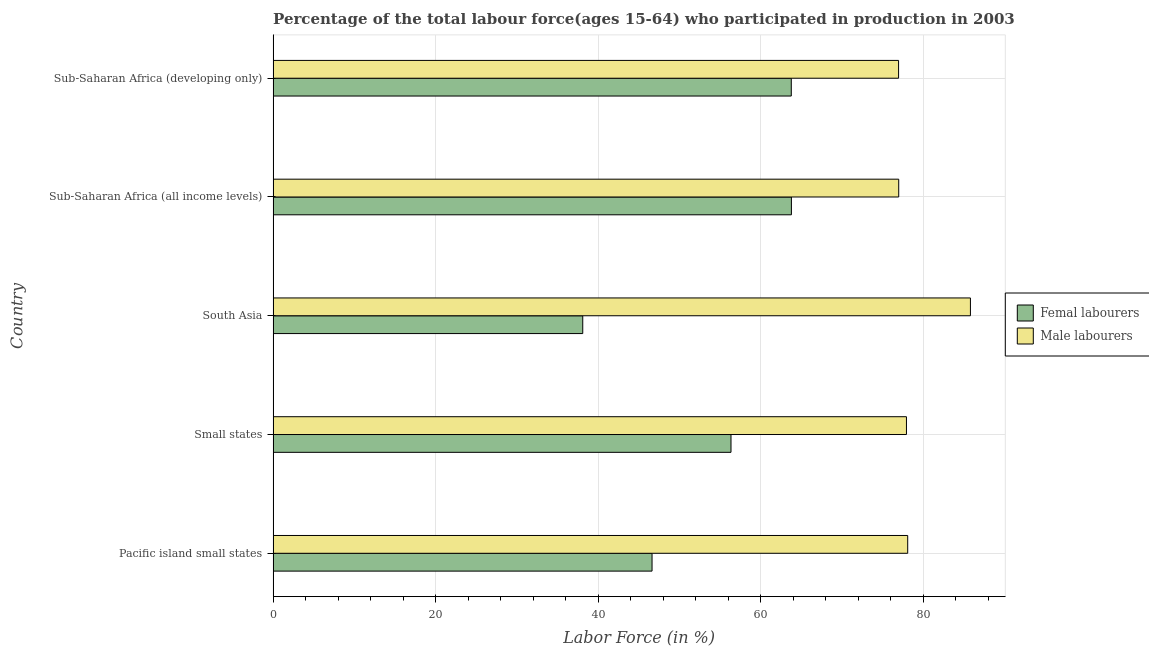How many different coloured bars are there?
Provide a succinct answer. 2. Are the number of bars per tick equal to the number of legend labels?
Your answer should be compact. Yes. Are the number of bars on each tick of the Y-axis equal?
Your answer should be compact. Yes. How many bars are there on the 2nd tick from the top?
Ensure brevity in your answer.  2. How many bars are there on the 3rd tick from the bottom?
Your answer should be compact. 2. In how many cases, is the number of bars for a given country not equal to the number of legend labels?
Offer a very short reply. 0. What is the percentage of male labour force in Small states?
Your answer should be very brief. 77.92. Across all countries, what is the maximum percentage of female labor force?
Your response must be concise. 63.77. Across all countries, what is the minimum percentage of female labor force?
Offer a terse response. 38.09. In which country was the percentage of female labor force maximum?
Ensure brevity in your answer.  Sub-Saharan Africa (all income levels). What is the total percentage of female labor force in the graph?
Make the answer very short. 268.56. What is the difference between the percentage of male labour force in Small states and that in Sub-Saharan Africa (developing only)?
Your response must be concise. 0.97. What is the difference between the percentage of female labor force in Sub-Saharan Africa (all income levels) and the percentage of male labour force in Small states?
Provide a succinct answer. -14.15. What is the average percentage of male labour force per country?
Offer a very short reply. 79.14. What is the difference between the percentage of female labor force and percentage of male labour force in Sub-Saharan Africa (all income levels)?
Provide a short and direct response. -13.2. What is the ratio of the percentage of female labor force in South Asia to that in Sub-Saharan Africa (all income levels)?
Your answer should be compact. 0.6. Is the percentage of female labor force in South Asia less than that in Sub-Saharan Africa (developing only)?
Keep it short and to the point. Yes. What is the difference between the highest and the second highest percentage of male labour force?
Make the answer very short. 7.72. What is the difference between the highest and the lowest percentage of female labor force?
Provide a succinct answer. 25.67. Is the sum of the percentage of female labor force in South Asia and Sub-Saharan Africa (all income levels) greater than the maximum percentage of male labour force across all countries?
Keep it short and to the point. Yes. What does the 2nd bar from the top in Sub-Saharan Africa (all income levels) represents?
Provide a short and direct response. Femal labourers. What does the 2nd bar from the bottom in Small states represents?
Ensure brevity in your answer.  Male labourers. How many countries are there in the graph?
Make the answer very short. 5. Does the graph contain grids?
Make the answer very short. Yes. What is the title of the graph?
Provide a succinct answer. Percentage of the total labour force(ages 15-64) who participated in production in 2003. Does "Travel Items" appear as one of the legend labels in the graph?
Keep it short and to the point. No. What is the label or title of the X-axis?
Offer a very short reply. Labor Force (in %). What is the Labor Force (in %) of Femal labourers in Pacific island small states?
Ensure brevity in your answer.  46.62. What is the Labor Force (in %) in Male labourers in Pacific island small states?
Keep it short and to the point. 78.07. What is the Labor Force (in %) of Femal labourers in Small states?
Provide a succinct answer. 56.33. What is the Labor Force (in %) of Male labourers in Small states?
Provide a succinct answer. 77.92. What is the Labor Force (in %) in Femal labourers in South Asia?
Ensure brevity in your answer.  38.09. What is the Labor Force (in %) of Male labourers in South Asia?
Provide a succinct answer. 85.79. What is the Labor Force (in %) in Femal labourers in Sub-Saharan Africa (all income levels)?
Provide a short and direct response. 63.77. What is the Labor Force (in %) of Male labourers in Sub-Saharan Africa (all income levels)?
Provide a succinct answer. 76.97. What is the Labor Force (in %) of Femal labourers in Sub-Saharan Africa (developing only)?
Give a very brief answer. 63.75. What is the Labor Force (in %) in Male labourers in Sub-Saharan Africa (developing only)?
Your answer should be very brief. 76.95. Across all countries, what is the maximum Labor Force (in %) of Femal labourers?
Your answer should be compact. 63.77. Across all countries, what is the maximum Labor Force (in %) in Male labourers?
Your answer should be compact. 85.79. Across all countries, what is the minimum Labor Force (in %) of Femal labourers?
Provide a short and direct response. 38.09. Across all countries, what is the minimum Labor Force (in %) of Male labourers?
Your answer should be compact. 76.95. What is the total Labor Force (in %) of Femal labourers in the graph?
Ensure brevity in your answer.  268.56. What is the total Labor Force (in %) in Male labourers in the graph?
Your answer should be compact. 395.7. What is the difference between the Labor Force (in %) of Femal labourers in Pacific island small states and that in Small states?
Provide a succinct answer. -9.71. What is the difference between the Labor Force (in %) in Male labourers in Pacific island small states and that in Small states?
Provide a succinct answer. 0.15. What is the difference between the Labor Force (in %) of Femal labourers in Pacific island small states and that in South Asia?
Provide a short and direct response. 8.53. What is the difference between the Labor Force (in %) in Male labourers in Pacific island small states and that in South Asia?
Your answer should be compact. -7.72. What is the difference between the Labor Force (in %) in Femal labourers in Pacific island small states and that in Sub-Saharan Africa (all income levels)?
Provide a short and direct response. -17.15. What is the difference between the Labor Force (in %) in Male labourers in Pacific island small states and that in Sub-Saharan Africa (all income levels)?
Provide a succinct answer. 1.11. What is the difference between the Labor Force (in %) of Femal labourers in Pacific island small states and that in Sub-Saharan Africa (developing only)?
Your response must be concise. -17.13. What is the difference between the Labor Force (in %) of Male labourers in Pacific island small states and that in Sub-Saharan Africa (developing only)?
Keep it short and to the point. 1.12. What is the difference between the Labor Force (in %) in Femal labourers in Small states and that in South Asia?
Make the answer very short. 18.24. What is the difference between the Labor Force (in %) of Male labourers in Small states and that in South Asia?
Make the answer very short. -7.87. What is the difference between the Labor Force (in %) in Femal labourers in Small states and that in Sub-Saharan Africa (all income levels)?
Offer a terse response. -7.43. What is the difference between the Labor Force (in %) in Male labourers in Small states and that in Sub-Saharan Africa (all income levels)?
Provide a short and direct response. 0.95. What is the difference between the Labor Force (in %) in Femal labourers in Small states and that in Sub-Saharan Africa (developing only)?
Your answer should be very brief. -7.42. What is the difference between the Labor Force (in %) of Male labourers in Small states and that in Sub-Saharan Africa (developing only)?
Give a very brief answer. 0.97. What is the difference between the Labor Force (in %) in Femal labourers in South Asia and that in Sub-Saharan Africa (all income levels)?
Provide a short and direct response. -25.67. What is the difference between the Labor Force (in %) in Male labourers in South Asia and that in Sub-Saharan Africa (all income levels)?
Your answer should be compact. 8.82. What is the difference between the Labor Force (in %) of Femal labourers in South Asia and that in Sub-Saharan Africa (developing only)?
Ensure brevity in your answer.  -25.66. What is the difference between the Labor Force (in %) in Male labourers in South Asia and that in Sub-Saharan Africa (developing only)?
Give a very brief answer. 8.84. What is the difference between the Labor Force (in %) in Femal labourers in Sub-Saharan Africa (all income levels) and that in Sub-Saharan Africa (developing only)?
Offer a very short reply. 0.01. What is the difference between the Labor Force (in %) of Male labourers in Sub-Saharan Africa (all income levels) and that in Sub-Saharan Africa (developing only)?
Your answer should be very brief. 0.02. What is the difference between the Labor Force (in %) in Femal labourers in Pacific island small states and the Labor Force (in %) in Male labourers in Small states?
Provide a succinct answer. -31.3. What is the difference between the Labor Force (in %) of Femal labourers in Pacific island small states and the Labor Force (in %) of Male labourers in South Asia?
Provide a short and direct response. -39.17. What is the difference between the Labor Force (in %) of Femal labourers in Pacific island small states and the Labor Force (in %) of Male labourers in Sub-Saharan Africa (all income levels)?
Provide a succinct answer. -30.35. What is the difference between the Labor Force (in %) of Femal labourers in Pacific island small states and the Labor Force (in %) of Male labourers in Sub-Saharan Africa (developing only)?
Ensure brevity in your answer.  -30.33. What is the difference between the Labor Force (in %) in Femal labourers in Small states and the Labor Force (in %) in Male labourers in South Asia?
Give a very brief answer. -29.46. What is the difference between the Labor Force (in %) in Femal labourers in Small states and the Labor Force (in %) in Male labourers in Sub-Saharan Africa (all income levels)?
Your answer should be very brief. -20.64. What is the difference between the Labor Force (in %) in Femal labourers in Small states and the Labor Force (in %) in Male labourers in Sub-Saharan Africa (developing only)?
Ensure brevity in your answer.  -20.62. What is the difference between the Labor Force (in %) in Femal labourers in South Asia and the Labor Force (in %) in Male labourers in Sub-Saharan Africa (all income levels)?
Ensure brevity in your answer.  -38.87. What is the difference between the Labor Force (in %) of Femal labourers in South Asia and the Labor Force (in %) of Male labourers in Sub-Saharan Africa (developing only)?
Keep it short and to the point. -38.86. What is the difference between the Labor Force (in %) of Femal labourers in Sub-Saharan Africa (all income levels) and the Labor Force (in %) of Male labourers in Sub-Saharan Africa (developing only)?
Your response must be concise. -13.19. What is the average Labor Force (in %) of Femal labourers per country?
Keep it short and to the point. 53.71. What is the average Labor Force (in %) in Male labourers per country?
Make the answer very short. 79.14. What is the difference between the Labor Force (in %) of Femal labourers and Labor Force (in %) of Male labourers in Pacific island small states?
Offer a very short reply. -31.45. What is the difference between the Labor Force (in %) of Femal labourers and Labor Force (in %) of Male labourers in Small states?
Ensure brevity in your answer.  -21.59. What is the difference between the Labor Force (in %) in Femal labourers and Labor Force (in %) in Male labourers in South Asia?
Ensure brevity in your answer.  -47.7. What is the difference between the Labor Force (in %) in Femal labourers and Labor Force (in %) in Male labourers in Sub-Saharan Africa (all income levels)?
Offer a terse response. -13.2. What is the difference between the Labor Force (in %) of Femal labourers and Labor Force (in %) of Male labourers in Sub-Saharan Africa (developing only)?
Provide a succinct answer. -13.2. What is the ratio of the Labor Force (in %) of Femal labourers in Pacific island small states to that in Small states?
Keep it short and to the point. 0.83. What is the ratio of the Labor Force (in %) of Femal labourers in Pacific island small states to that in South Asia?
Offer a very short reply. 1.22. What is the ratio of the Labor Force (in %) in Male labourers in Pacific island small states to that in South Asia?
Your response must be concise. 0.91. What is the ratio of the Labor Force (in %) of Femal labourers in Pacific island small states to that in Sub-Saharan Africa (all income levels)?
Your response must be concise. 0.73. What is the ratio of the Labor Force (in %) of Male labourers in Pacific island small states to that in Sub-Saharan Africa (all income levels)?
Keep it short and to the point. 1.01. What is the ratio of the Labor Force (in %) of Femal labourers in Pacific island small states to that in Sub-Saharan Africa (developing only)?
Make the answer very short. 0.73. What is the ratio of the Labor Force (in %) of Male labourers in Pacific island small states to that in Sub-Saharan Africa (developing only)?
Your answer should be very brief. 1.01. What is the ratio of the Labor Force (in %) of Femal labourers in Small states to that in South Asia?
Ensure brevity in your answer.  1.48. What is the ratio of the Labor Force (in %) of Male labourers in Small states to that in South Asia?
Offer a terse response. 0.91. What is the ratio of the Labor Force (in %) of Femal labourers in Small states to that in Sub-Saharan Africa (all income levels)?
Offer a very short reply. 0.88. What is the ratio of the Labor Force (in %) of Male labourers in Small states to that in Sub-Saharan Africa (all income levels)?
Offer a terse response. 1.01. What is the ratio of the Labor Force (in %) in Femal labourers in Small states to that in Sub-Saharan Africa (developing only)?
Ensure brevity in your answer.  0.88. What is the ratio of the Labor Force (in %) in Male labourers in Small states to that in Sub-Saharan Africa (developing only)?
Your response must be concise. 1.01. What is the ratio of the Labor Force (in %) of Femal labourers in South Asia to that in Sub-Saharan Africa (all income levels)?
Your answer should be very brief. 0.6. What is the ratio of the Labor Force (in %) in Male labourers in South Asia to that in Sub-Saharan Africa (all income levels)?
Offer a very short reply. 1.11. What is the ratio of the Labor Force (in %) in Femal labourers in South Asia to that in Sub-Saharan Africa (developing only)?
Provide a succinct answer. 0.6. What is the ratio of the Labor Force (in %) of Male labourers in South Asia to that in Sub-Saharan Africa (developing only)?
Provide a succinct answer. 1.11. What is the ratio of the Labor Force (in %) of Male labourers in Sub-Saharan Africa (all income levels) to that in Sub-Saharan Africa (developing only)?
Your answer should be compact. 1. What is the difference between the highest and the second highest Labor Force (in %) in Femal labourers?
Provide a succinct answer. 0.01. What is the difference between the highest and the second highest Labor Force (in %) in Male labourers?
Your response must be concise. 7.72. What is the difference between the highest and the lowest Labor Force (in %) of Femal labourers?
Provide a succinct answer. 25.67. What is the difference between the highest and the lowest Labor Force (in %) in Male labourers?
Provide a short and direct response. 8.84. 